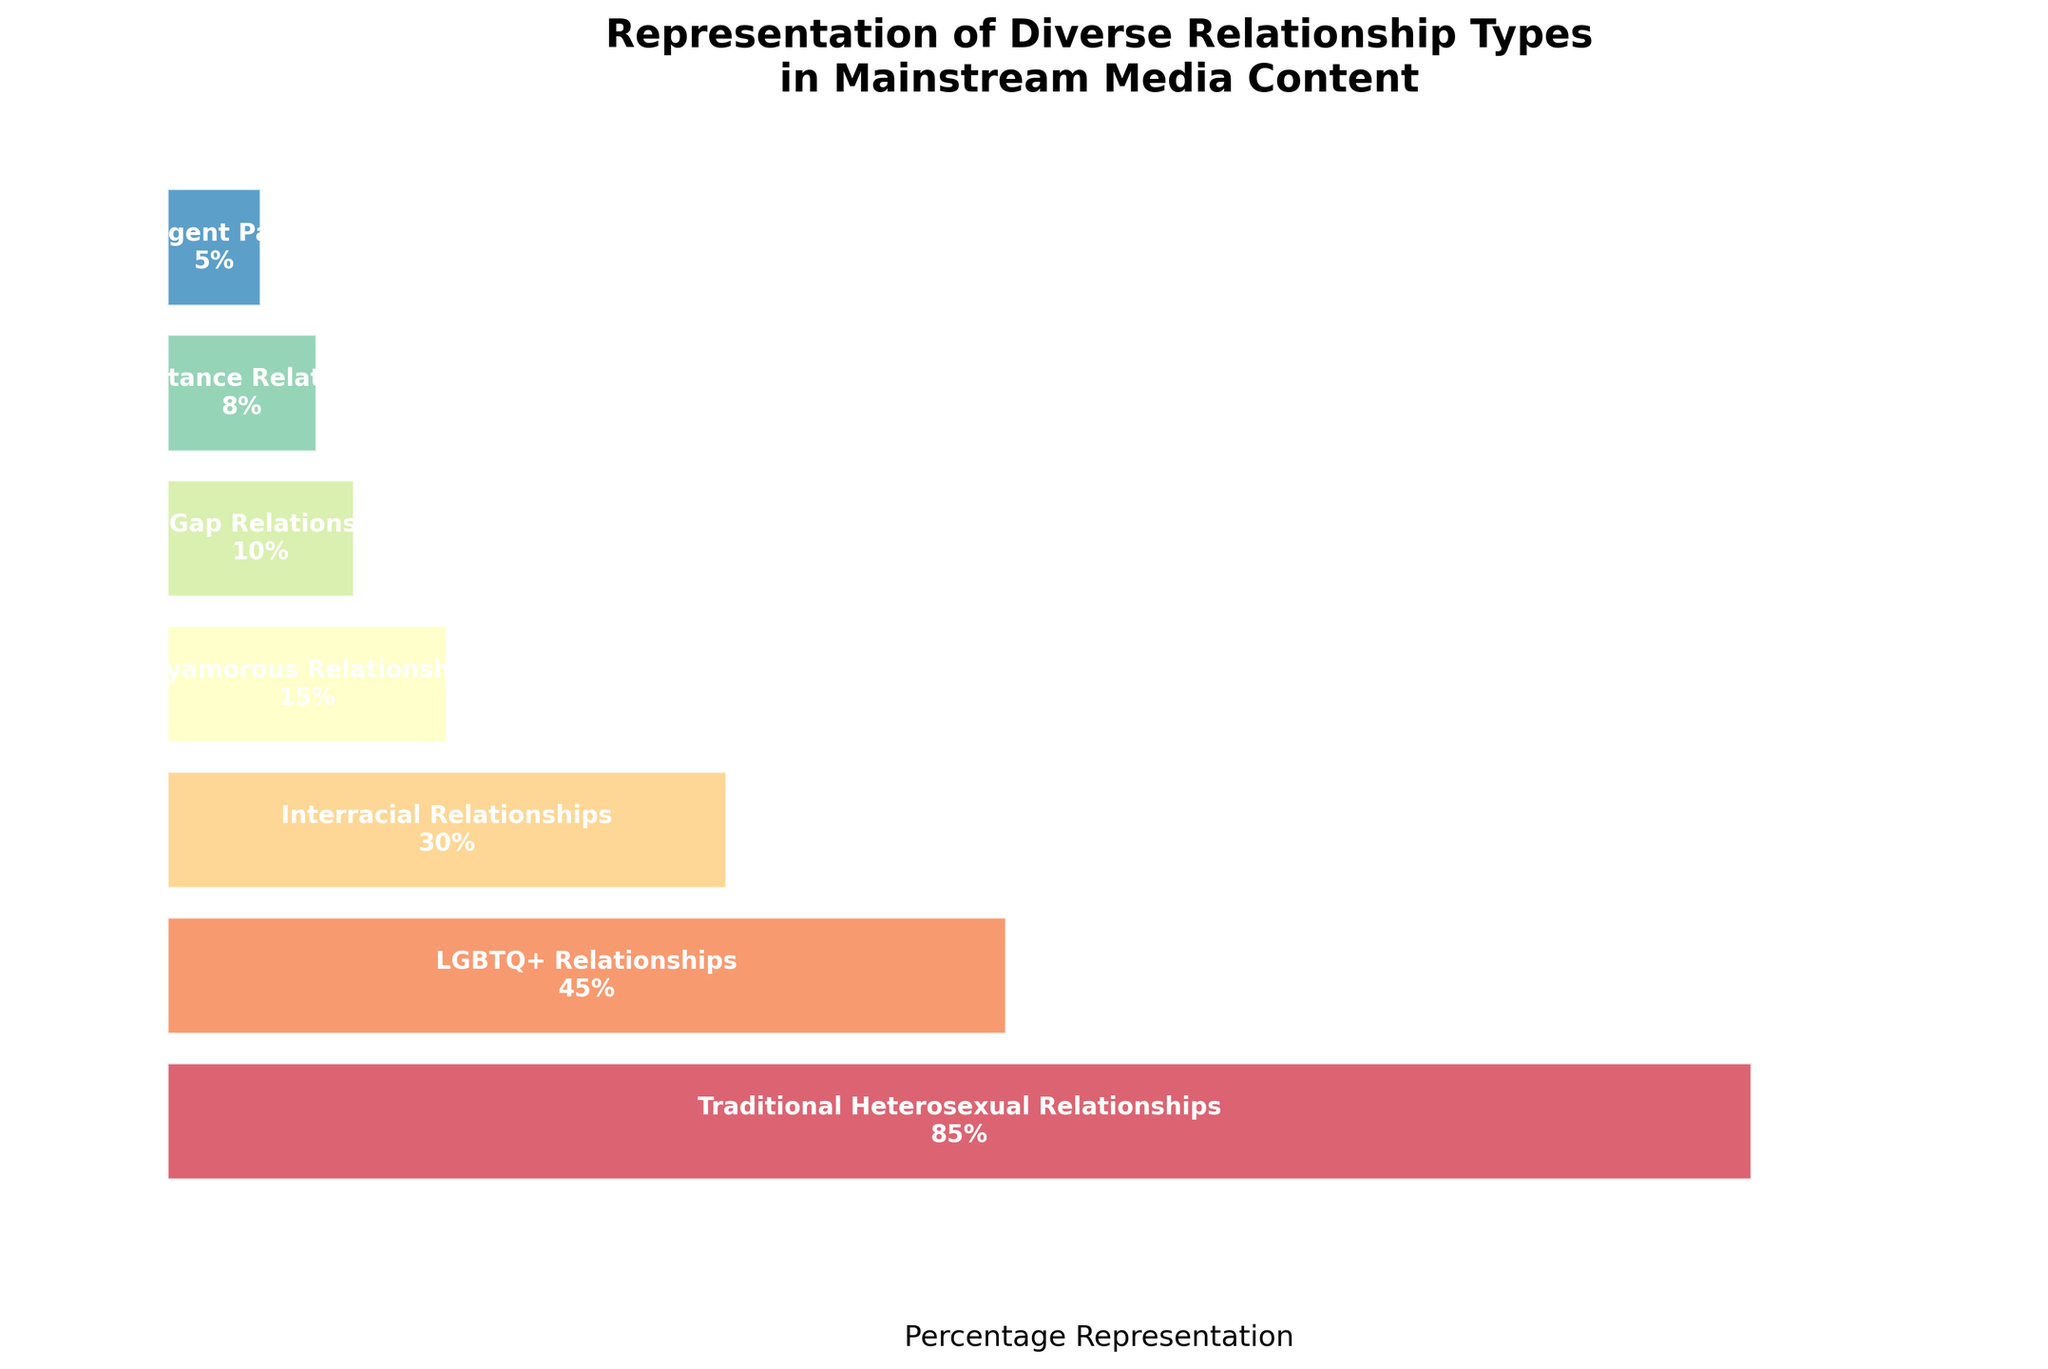What title does the figure display? The title is the text at the top of the figure that provides a summary of what the data represents. The title states what the entire visualization is about.
Answer: Representation of Diverse Relationship Types in Mainstream Media Content How many relationship types are represented in the figure? To determine the number of relationship types, count the distinct bars or categories listed on the y-axis.
Answer: 7 Which relationship type has the highest percentage representation? To find this, look for the longest bar or the one with the highest percentage value next to it.
Answer: Traditional Heterosexual Relationships What is the percentage representation of Interracial Relationships? Locate the bar labeled "Interracial Relationships" and read the percentage value displayed within or next to the bar.
Answer: 30% What is the combined percentage of Polyamorous Relationships and Age-Gap Relationships? Add the percentage values for both "Polyamorous Relationships" and "Age-Gap Relationships": 15% + 10% = 25%.
Answer: 25% Compare the percentage representation of LGBTQ+ Relationships and Neurodivergent Partnerships. Which has a higher value and by how much? Subtract the percentage of Neurodivergent Partnerships from LGBTQ+ Relationships: 45% - 5% = 40%. Therefore, LGBTQ+ Relationships have a higher value by 40%.
Answer: LGBTQ+ by 40% What is the difference in percentage representation between the highest and lowest represented relationship types? Subtract the percentage of the least represented type (Neurodivergent Partnerships, 5%) from the most represented type (Traditional Heterosexual Relationships, 85%): 85% - 5% = 80%.
Answer: 80% What is the average percentage representation of all the relationship types combined? Sum all percentage values and divide by the number of relationship types: (85 + 45 + 30 + 15 + 10 + 8 + 5) / 7 = 28.29%.
Answer: 28.29% What percentage representation do Long-Distance Relationships and Neurodivergent Partnerships have together? Add the percentages for both types: 8% + 5% = 13%.
Answer: 13% Which relationship type is represented less, Age-Gap Relationships or Long-Distance Relationships? Compare the percentages for Age-Gap Relationships (10%) and Long-Distance Relationships (8%). Long-Distance Relationships have the lower percentage.
Answer: Long-Distance Relationships 